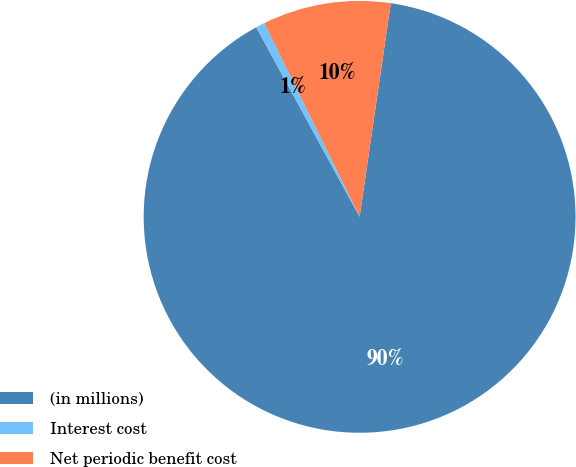Convert chart to OTSL. <chart><loc_0><loc_0><loc_500><loc_500><pie_chart><fcel>(in millions)<fcel>Interest cost<fcel>Net periodic benefit cost<nl><fcel>89.75%<fcel>0.67%<fcel>9.58%<nl></chart> 